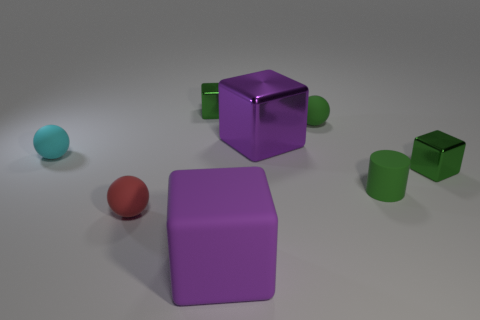Subtract 1 blocks. How many blocks are left? 3 Subtract all brown blocks. Subtract all cyan balls. How many blocks are left? 4 Add 2 large things. How many objects exist? 10 Subtract all spheres. How many objects are left? 5 Subtract 0 cyan cylinders. How many objects are left? 8 Subtract all big brown shiny cubes. Subtract all small green objects. How many objects are left? 4 Add 3 metallic things. How many metallic things are left? 6 Add 7 green shiny cubes. How many green shiny cubes exist? 9 